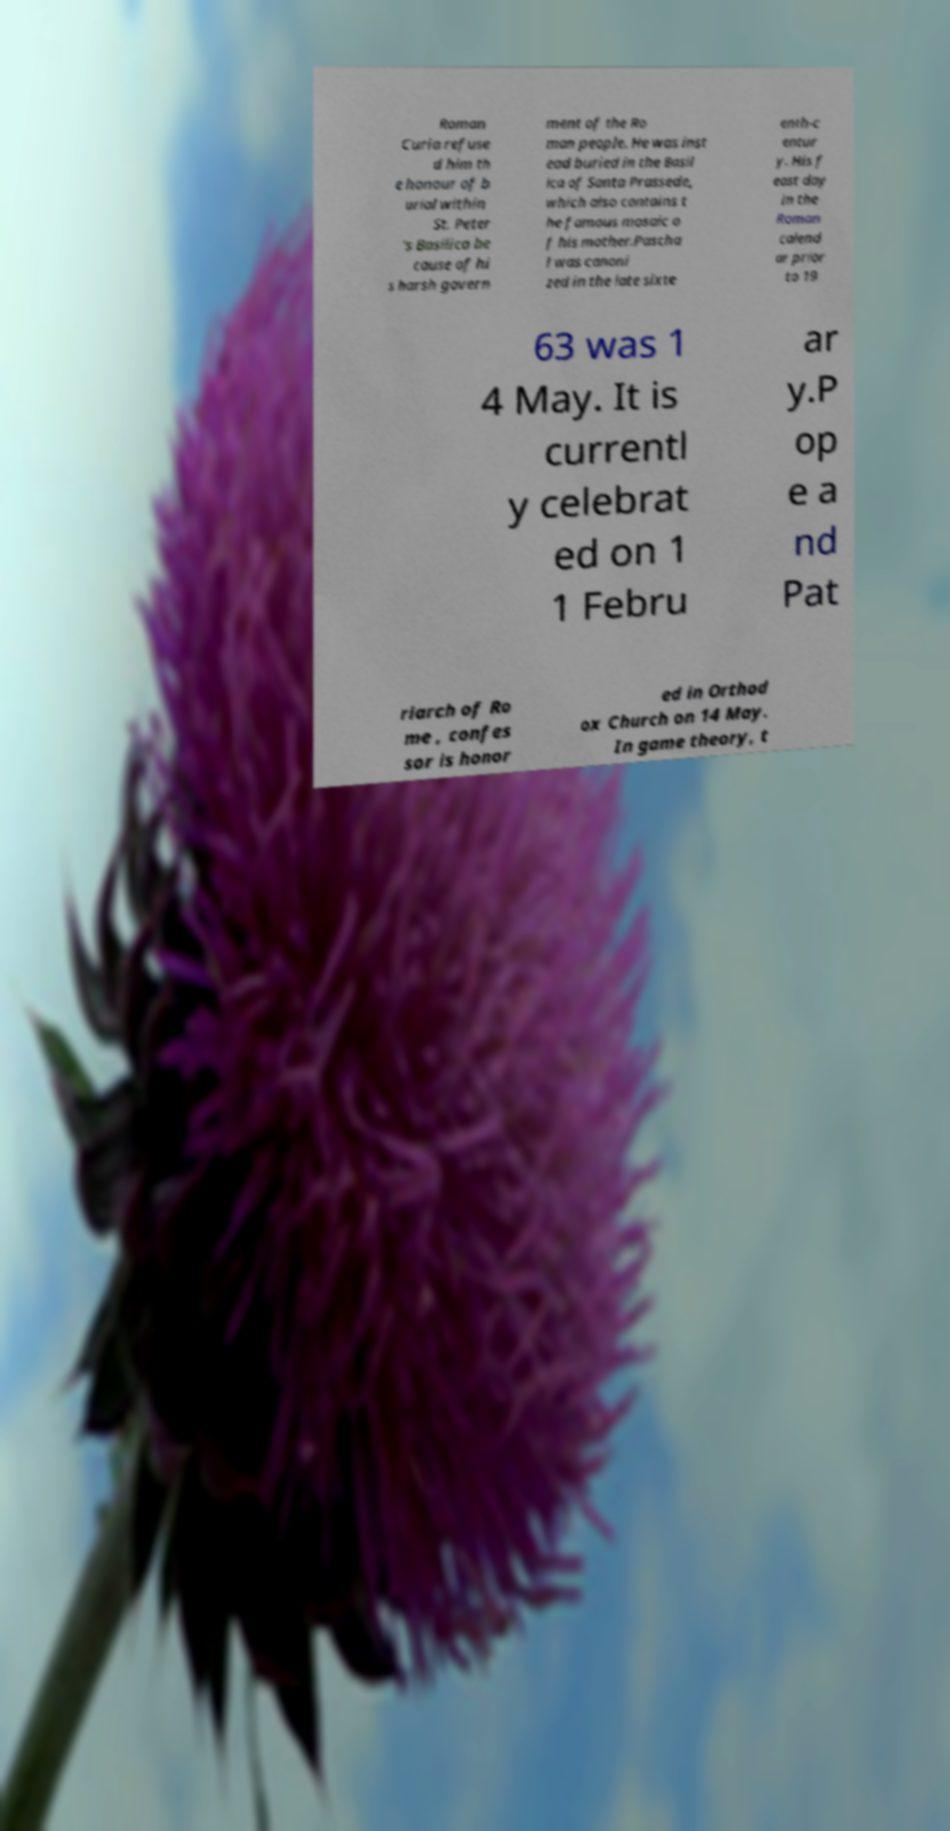There's text embedded in this image that I need extracted. Can you transcribe it verbatim? Roman Curia refuse d him th e honour of b urial within St. Peter 's Basilica be cause of hi s harsh govern ment of the Ro man people. He was inst ead buried in the Basil ica of Santa Prassede, which also contains t he famous mosaic o f his mother.Pascha l was canoni zed in the late sixte enth-c entur y. His f east day in the Roman calend ar prior to 19 63 was 1 4 May. It is currentl y celebrat ed on 1 1 Febru ar y.P op e a nd Pat riarch of Ro me , confes sor is honor ed in Orthod ox Church on 14 May. In game theory, t 